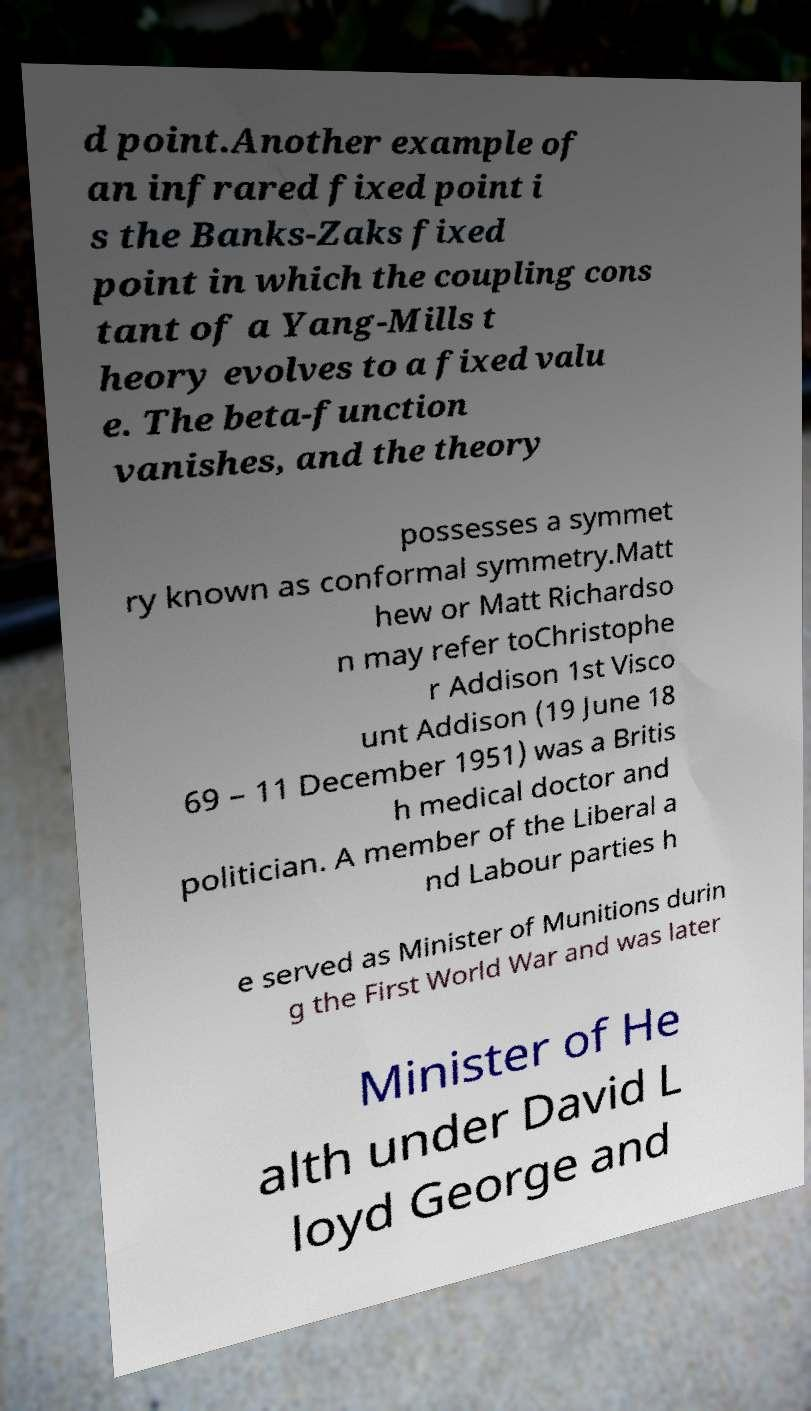Can you read and provide the text displayed in the image?This photo seems to have some interesting text. Can you extract and type it out for me? d point.Another example of an infrared fixed point i s the Banks-Zaks fixed point in which the coupling cons tant of a Yang-Mills t heory evolves to a fixed valu e. The beta-function vanishes, and the theory possesses a symmet ry known as conformal symmetry.Matt hew or Matt Richardso n may refer toChristophe r Addison 1st Visco unt Addison (19 June 18 69 – 11 December 1951) was a Britis h medical doctor and politician. A member of the Liberal a nd Labour parties h e served as Minister of Munitions durin g the First World War and was later Minister of He alth under David L loyd George and 